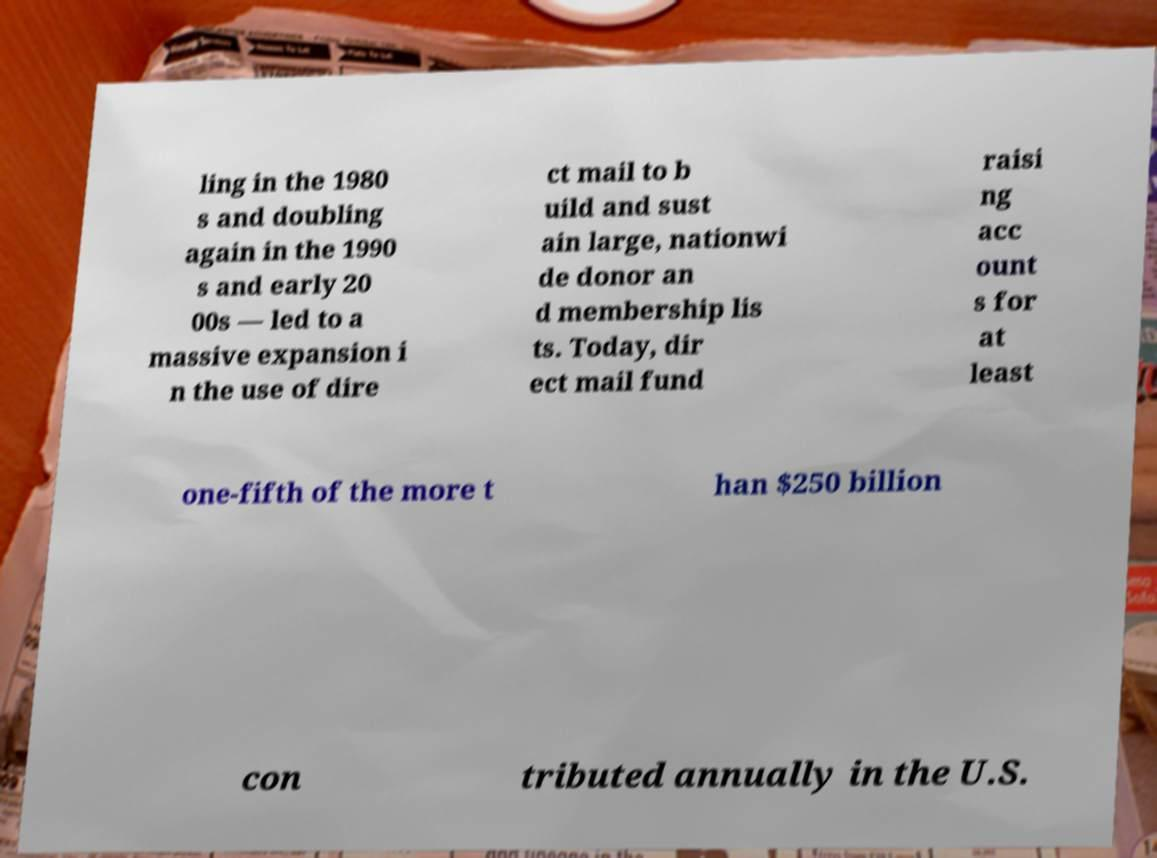Can you read and provide the text displayed in the image?This photo seems to have some interesting text. Can you extract and type it out for me? ling in the 1980 s and doubling again in the 1990 s and early 20 00s — led to a massive expansion i n the use of dire ct mail to b uild and sust ain large, nationwi de donor an d membership lis ts. Today, dir ect mail fund raisi ng acc ount s for at least one-fifth of the more t han $250 billion con tributed annually in the U.S. 